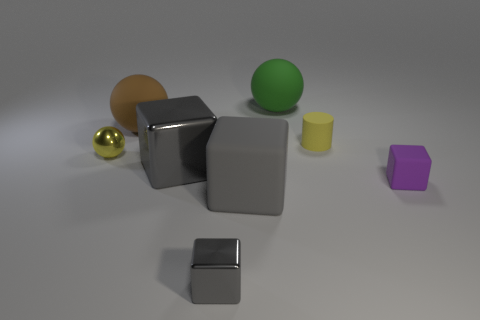Subtract all gray balls. How many gray blocks are left? 3 Add 1 brown objects. How many objects exist? 9 Subtract all balls. How many objects are left? 5 Subtract 0 blue cubes. How many objects are left? 8 Subtract all tiny gray things. Subtract all large metal objects. How many objects are left? 6 Add 5 yellow shiny balls. How many yellow shiny balls are left? 6 Add 7 big yellow cubes. How many big yellow cubes exist? 7 